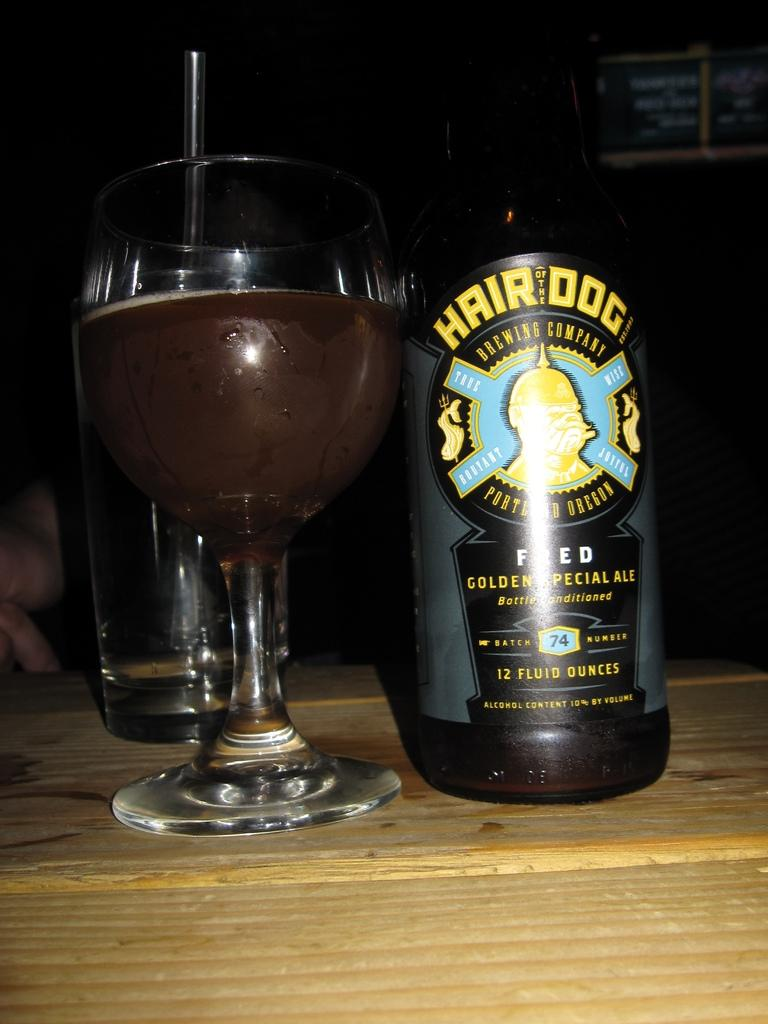<image>
Share a concise interpretation of the image provided. A bottle of Hair of the Dog beer by a glass 